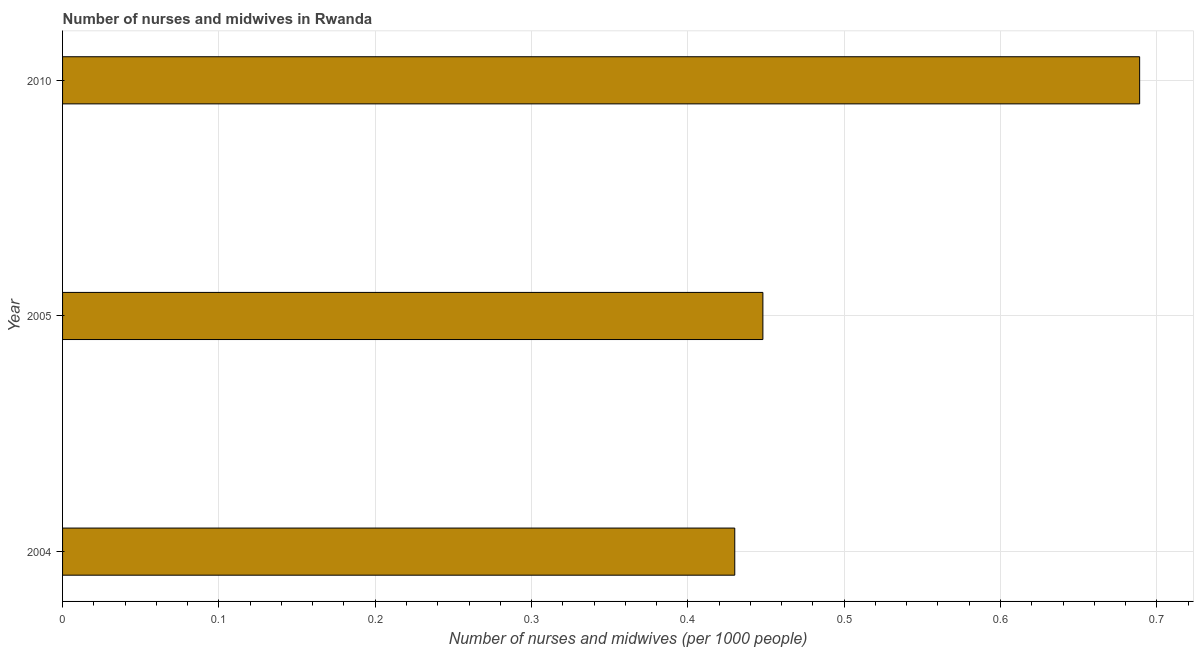Does the graph contain any zero values?
Your answer should be compact. No. Does the graph contain grids?
Offer a terse response. Yes. What is the title of the graph?
Keep it short and to the point. Number of nurses and midwives in Rwanda. What is the label or title of the X-axis?
Give a very brief answer. Number of nurses and midwives (per 1000 people). What is the number of nurses and midwives in 2004?
Ensure brevity in your answer.  0.43. Across all years, what is the maximum number of nurses and midwives?
Make the answer very short. 0.69. Across all years, what is the minimum number of nurses and midwives?
Give a very brief answer. 0.43. In which year was the number of nurses and midwives minimum?
Ensure brevity in your answer.  2004. What is the sum of the number of nurses and midwives?
Provide a short and direct response. 1.57. What is the difference between the number of nurses and midwives in 2004 and 2005?
Keep it short and to the point. -0.02. What is the average number of nurses and midwives per year?
Ensure brevity in your answer.  0.52. What is the median number of nurses and midwives?
Offer a terse response. 0.45. In how many years, is the number of nurses and midwives greater than 0.26 ?
Offer a terse response. 3. Do a majority of the years between 2004 and 2005 (inclusive) have number of nurses and midwives greater than 0.02 ?
Your answer should be compact. Yes. What is the ratio of the number of nurses and midwives in 2004 to that in 2010?
Provide a short and direct response. 0.62. Is the number of nurses and midwives in 2004 less than that in 2005?
Provide a succinct answer. Yes. What is the difference between the highest and the second highest number of nurses and midwives?
Keep it short and to the point. 0.24. What is the difference between the highest and the lowest number of nurses and midwives?
Offer a very short reply. 0.26. In how many years, is the number of nurses and midwives greater than the average number of nurses and midwives taken over all years?
Keep it short and to the point. 1. How many bars are there?
Offer a terse response. 3. Are all the bars in the graph horizontal?
Give a very brief answer. Yes. How many years are there in the graph?
Your answer should be very brief. 3. What is the difference between two consecutive major ticks on the X-axis?
Your response must be concise. 0.1. Are the values on the major ticks of X-axis written in scientific E-notation?
Your response must be concise. No. What is the Number of nurses and midwives (per 1000 people) in 2004?
Keep it short and to the point. 0.43. What is the Number of nurses and midwives (per 1000 people) of 2005?
Your response must be concise. 0.45. What is the Number of nurses and midwives (per 1000 people) of 2010?
Provide a succinct answer. 0.69. What is the difference between the Number of nurses and midwives (per 1000 people) in 2004 and 2005?
Give a very brief answer. -0.02. What is the difference between the Number of nurses and midwives (per 1000 people) in 2004 and 2010?
Offer a terse response. -0.26. What is the difference between the Number of nurses and midwives (per 1000 people) in 2005 and 2010?
Offer a terse response. -0.24. What is the ratio of the Number of nurses and midwives (per 1000 people) in 2004 to that in 2010?
Your answer should be very brief. 0.62. What is the ratio of the Number of nurses and midwives (per 1000 people) in 2005 to that in 2010?
Ensure brevity in your answer.  0.65. 